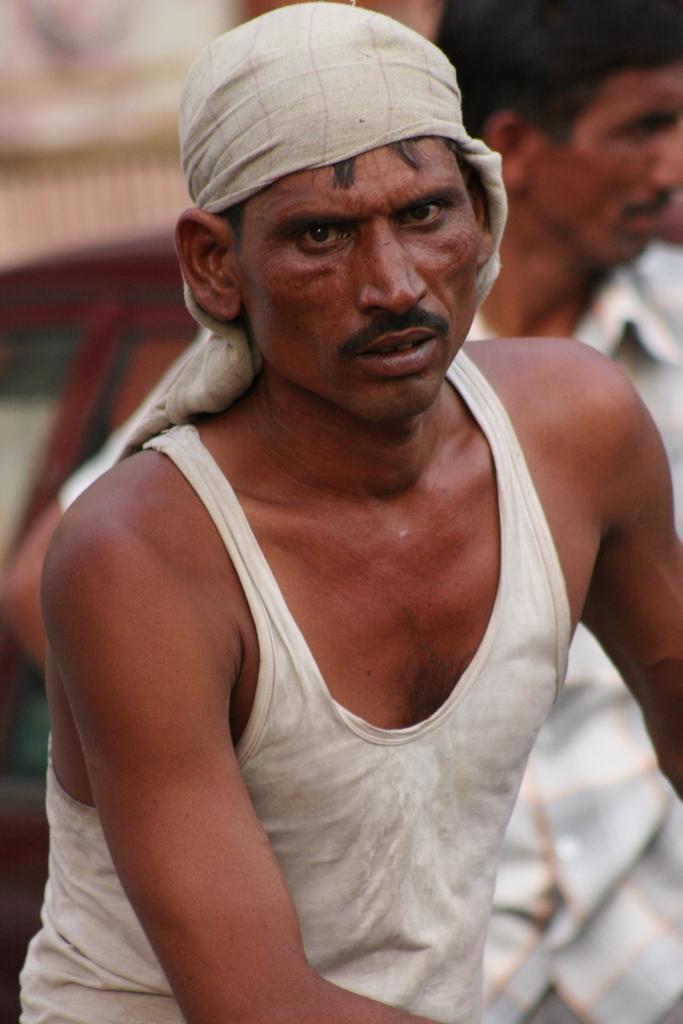What is the clothing of the man in the image? The man is wearing a white color banian. What is the man doing with the cloth on his head? The man has a cloth on his head, which might be for protection or religious reasons. How many men are in the image? There are two men in the image. What is the clothing of the second man? The second man is wearing a white shirt. What type of wound can be seen on the man's arm in the image? There is no wound visible on the man's arm in the image. Where is the war taking place in the image? There is no war present in the image; it features two men. 